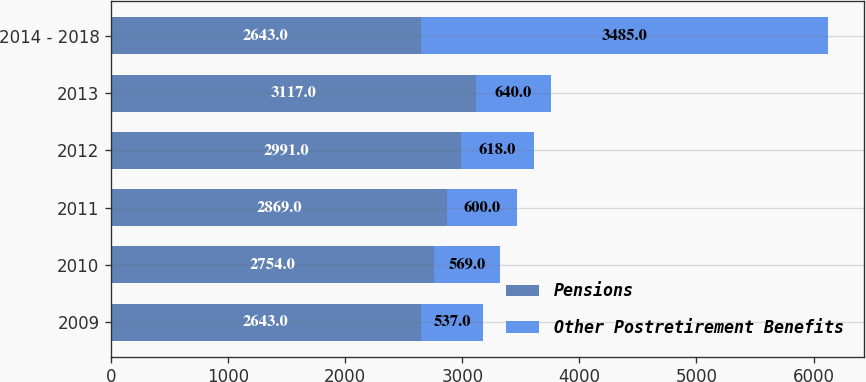Convert chart. <chart><loc_0><loc_0><loc_500><loc_500><stacked_bar_chart><ecel><fcel>2009<fcel>2010<fcel>2011<fcel>2012<fcel>2013<fcel>2014 - 2018<nl><fcel>Pensions<fcel>2643<fcel>2754<fcel>2869<fcel>2991<fcel>3117<fcel>2643<nl><fcel>Other Postretirement Benefits<fcel>537<fcel>569<fcel>600<fcel>618<fcel>640<fcel>3485<nl></chart> 